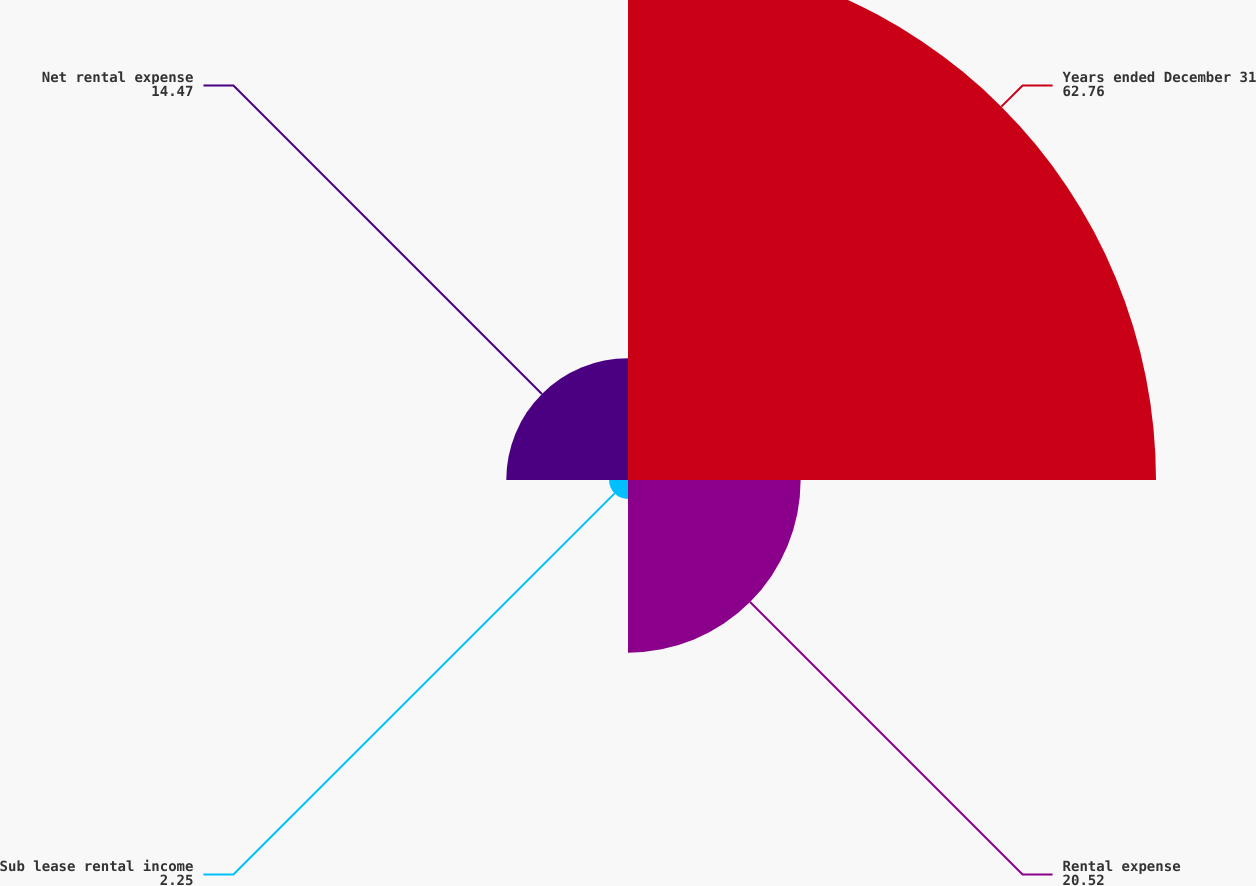Convert chart to OTSL. <chart><loc_0><loc_0><loc_500><loc_500><pie_chart><fcel>Years ended December 31<fcel>Rental expense<fcel>Sub lease rental income<fcel>Net rental expense<nl><fcel>62.76%<fcel>20.52%<fcel>2.25%<fcel>14.47%<nl></chart> 